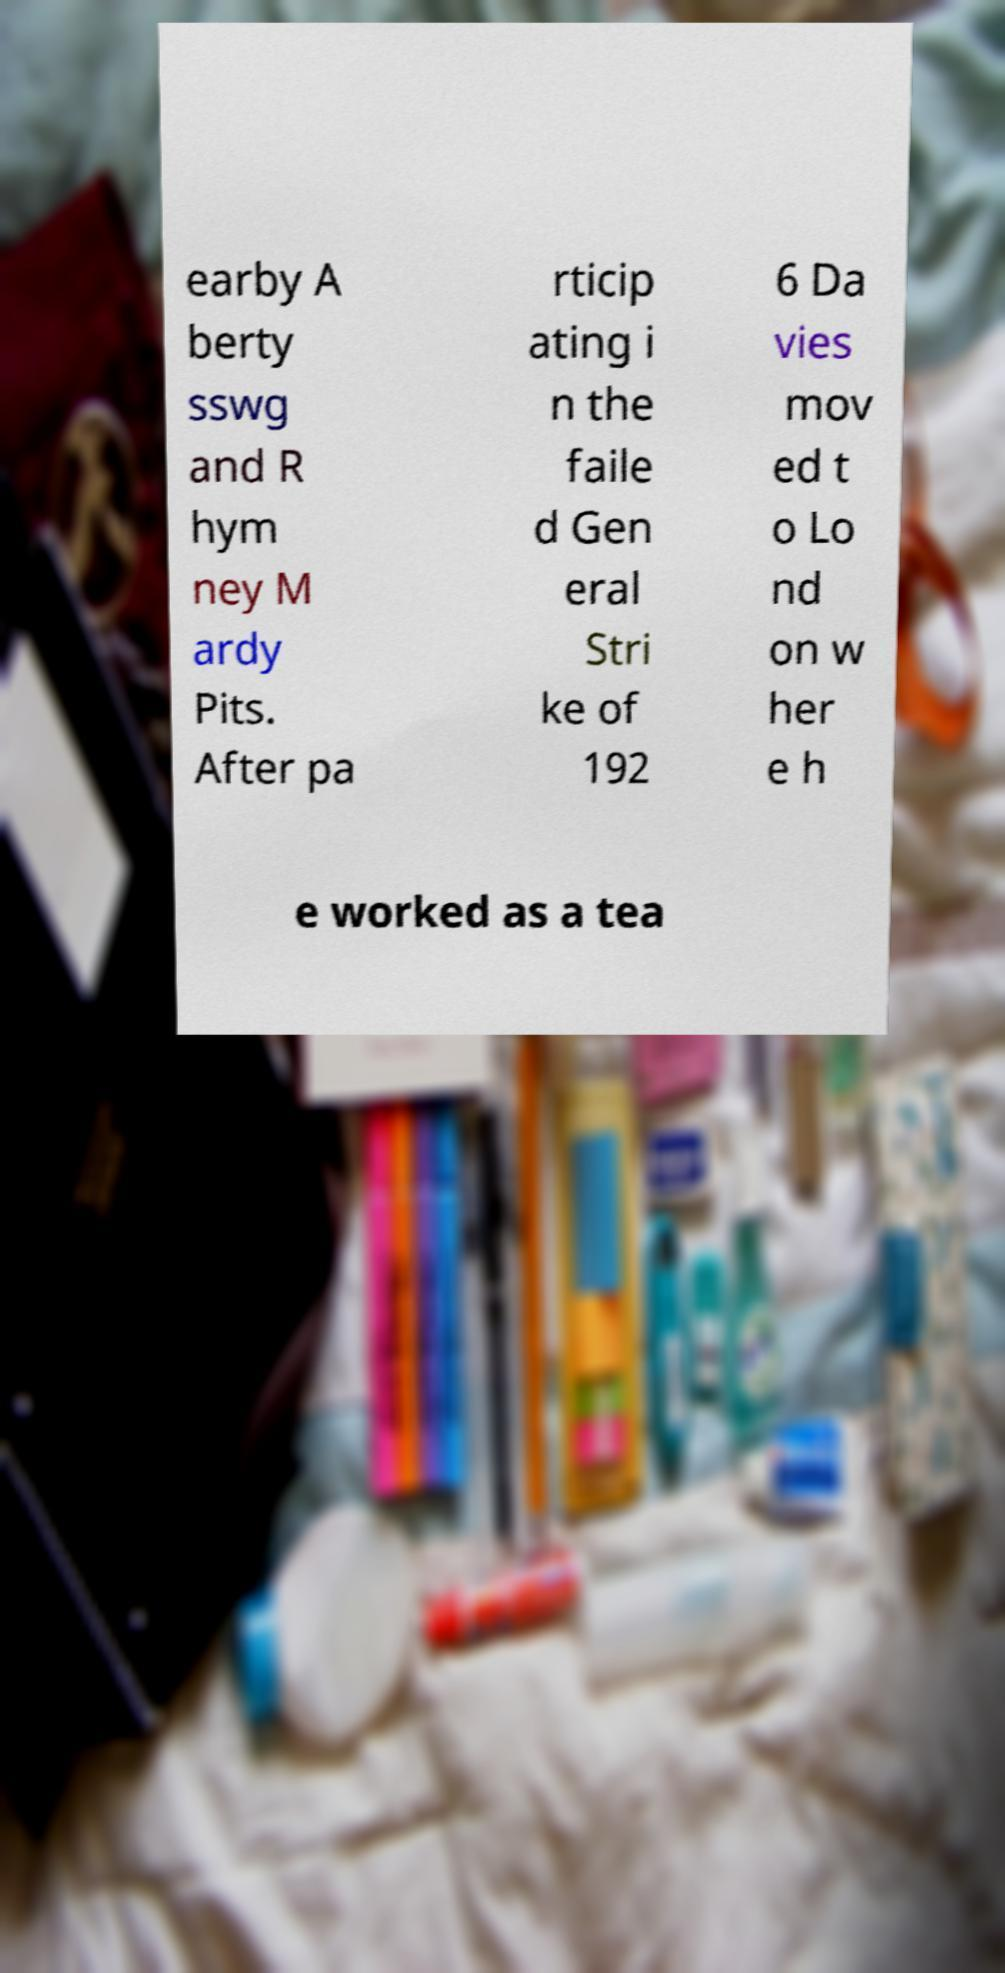I need the written content from this picture converted into text. Can you do that? earby A berty sswg and R hym ney M ardy Pits. After pa rticip ating i n the faile d Gen eral Stri ke of 192 6 Da vies mov ed t o Lo nd on w her e h e worked as a tea 